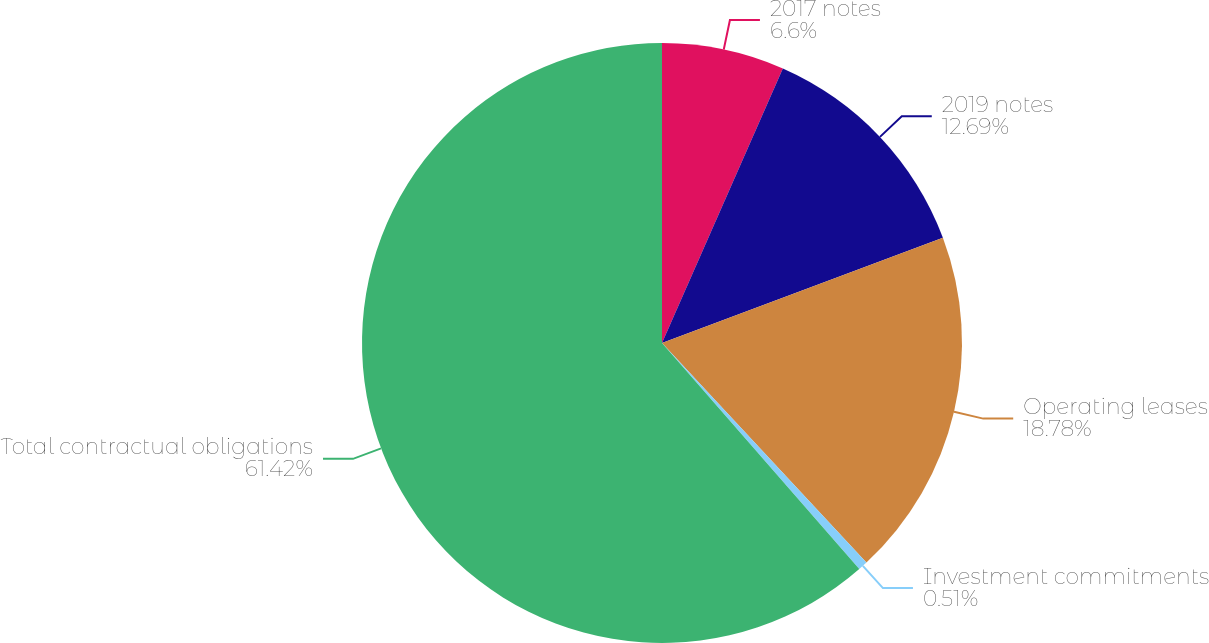<chart> <loc_0><loc_0><loc_500><loc_500><pie_chart><fcel>2017 notes<fcel>2019 notes<fcel>Operating leases<fcel>Investment commitments<fcel>Total contractual obligations<nl><fcel>6.6%<fcel>12.69%<fcel>18.78%<fcel>0.51%<fcel>61.42%<nl></chart> 